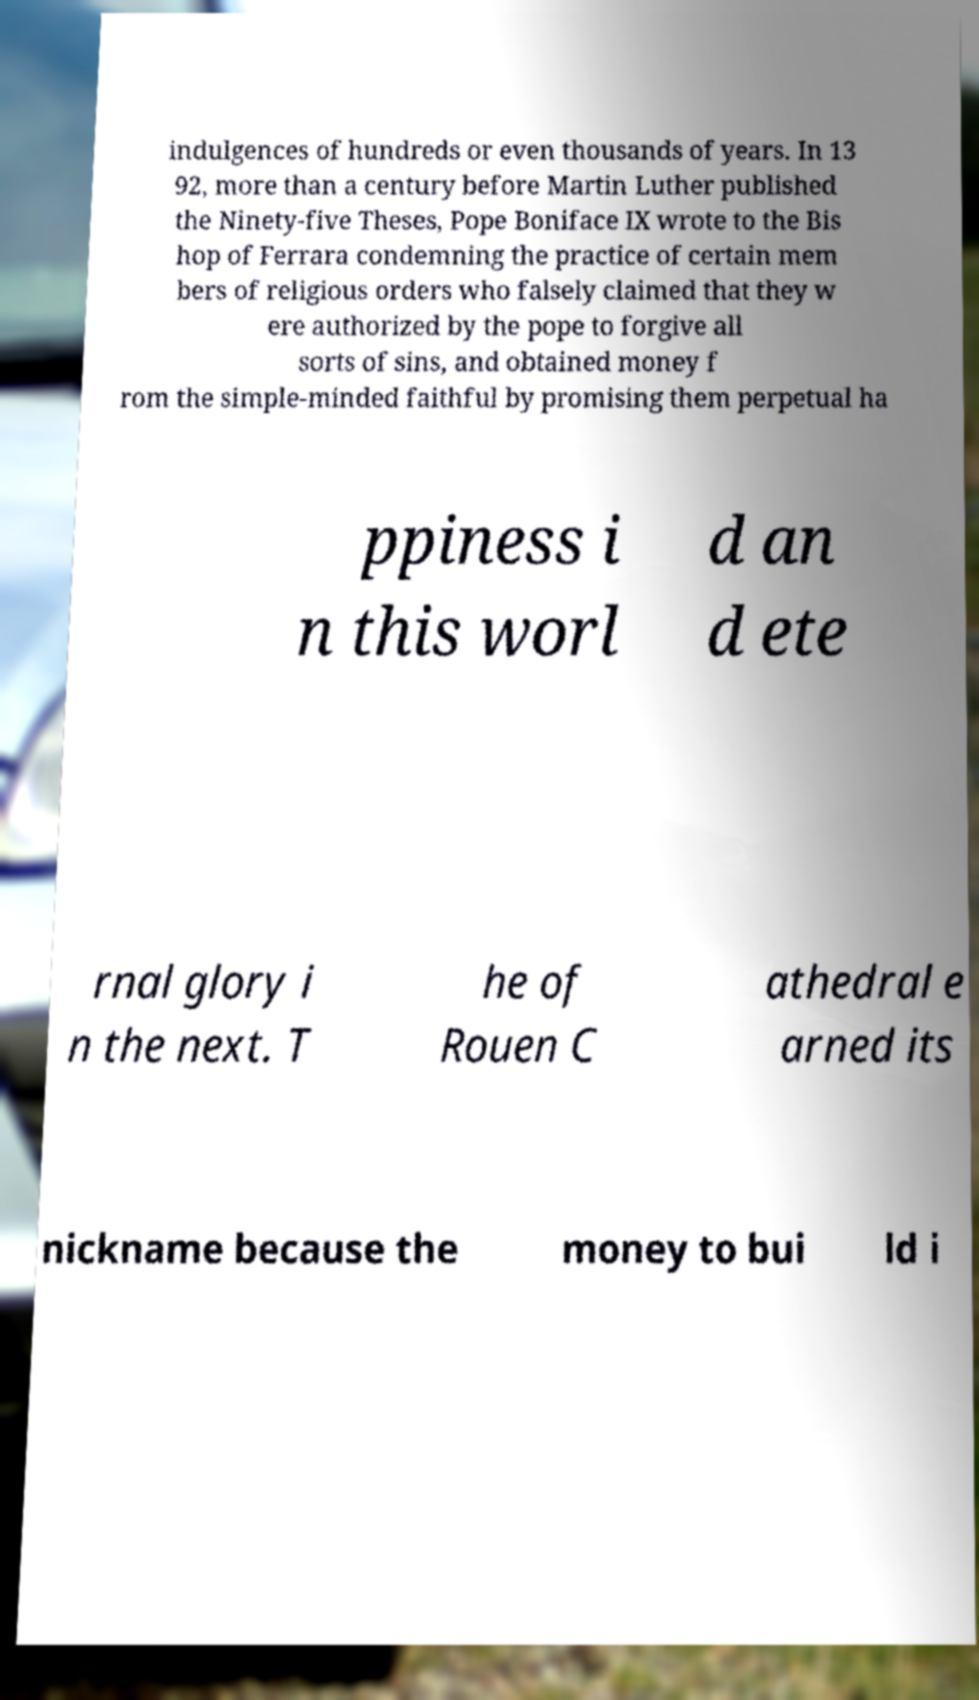Can you read and provide the text displayed in the image?This photo seems to have some interesting text. Can you extract and type it out for me? indulgences of hundreds or even thousands of years. In 13 92, more than a century before Martin Luther published the Ninety-five Theses, Pope Boniface IX wrote to the Bis hop of Ferrara condemning the practice of certain mem bers of religious orders who falsely claimed that they w ere authorized by the pope to forgive all sorts of sins, and obtained money f rom the simple-minded faithful by promising them perpetual ha ppiness i n this worl d an d ete rnal glory i n the next. T he of Rouen C athedral e arned its nickname because the money to bui ld i 